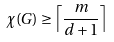Convert formula to latex. <formula><loc_0><loc_0><loc_500><loc_500>\chi ( G ) \geq \left \lceil \frac { m } { d + 1 } \right \rceil</formula> 